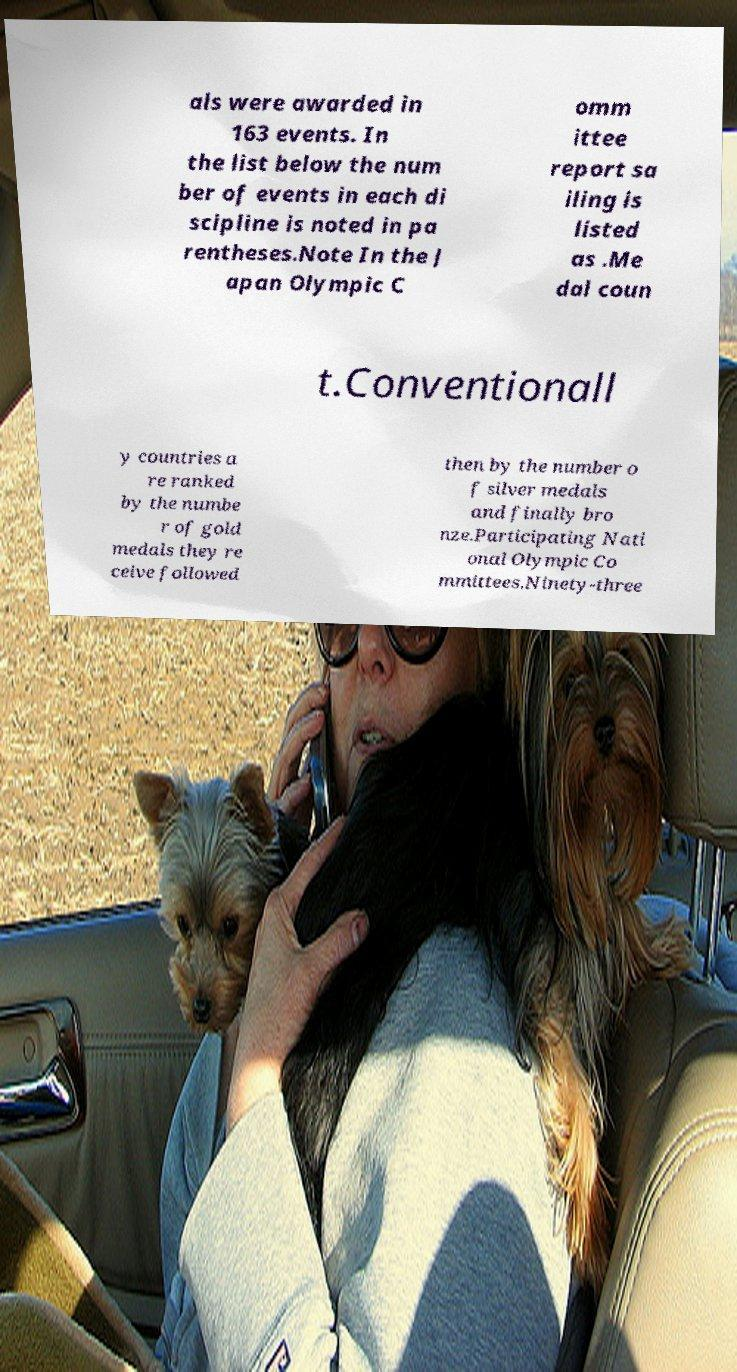There's text embedded in this image that I need extracted. Can you transcribe it verbatim? als were awarded in 163 events. In the list below the num ber of events in each di scipline is noted in pa rentheses.Note In the J apan Olympic C omm ittee report sa iling is listed as .Me dal coun t.Conventionall y countries a re ranked by the numbe r of gold medals they re ceive followed then by the number o f silver medals and finally bro nze.Participating Nati onal Olympic Co mmittees.Ninety-three 